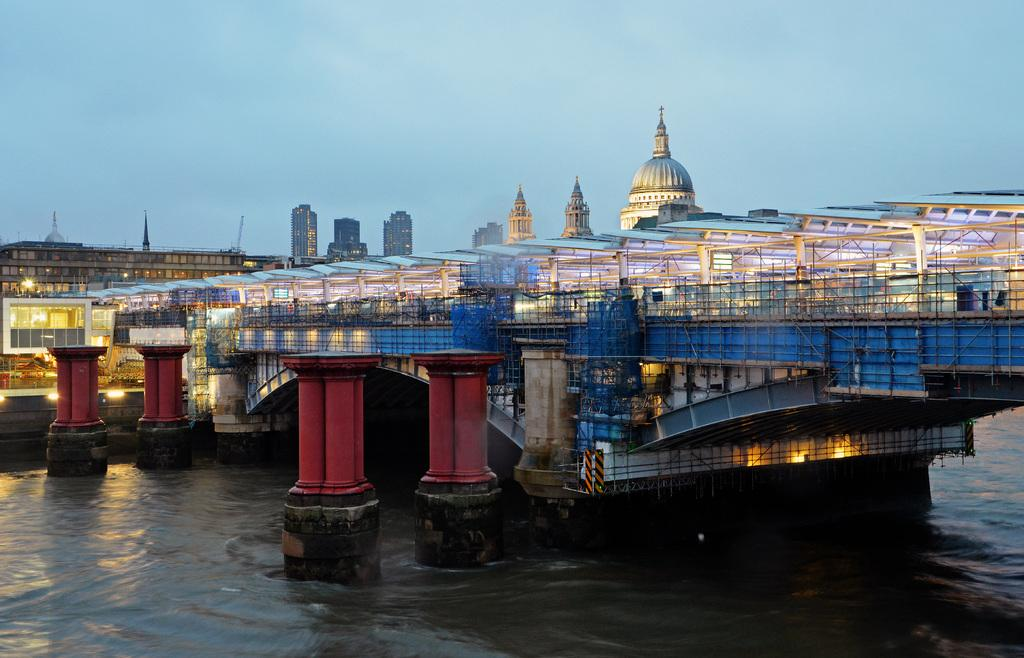What type of body of water is visible in the image? There is a lake in the image. What structure can be seen crossing the lake? There is a bridge in the image. What feature of the bridge is mentioned in the facts? The bridge has pillars. What else can be seen in the image besides the lake and bridge? There are buildings in the image. How would you describe the weather based on the sky in the image? The sky is clear in the image, suggesting good weather. Can you tell me how many horses are standing on the bridge in the image? There are no horses present in the image; it features a lake, a bridge with pillars, buildings, and a clear sky. What color is the neck of the horse in the image? There is no horse present in the image, so there is no neck to describe. 